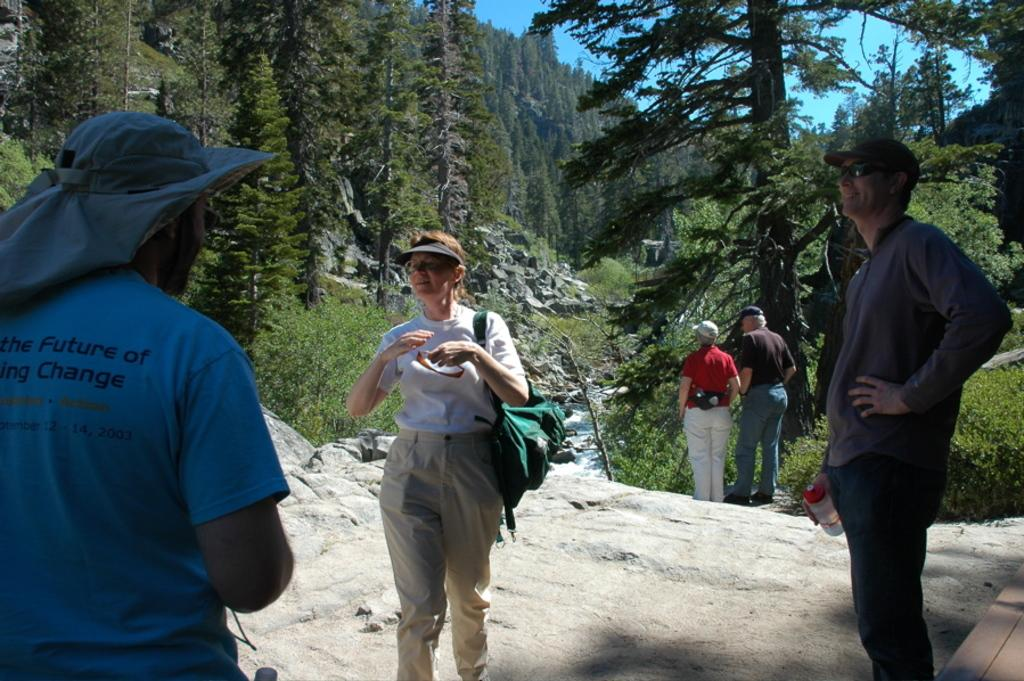How many people are present in the image? There are five persons in the image. Where are the persons standing in the image? The persons are standing on a rock. What can be seen in the background of the image? There are trees in the background of the image. What type of agreement is being signed by the persons in the image? There is no indication in the image that the persons are signing any agreement. 